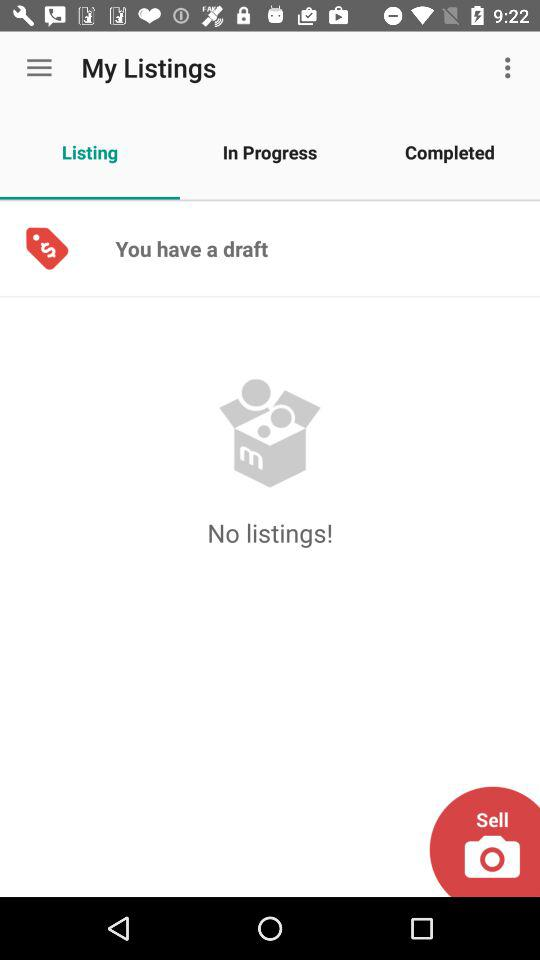Is there any "Listing"? There is no "Listing". 